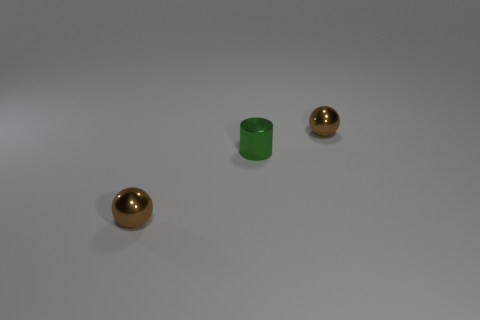Add 2 metallic things. How many objects exist? 5 Subtract 1 cylinders. How many cylinders are left? 0 Subtract all red cylinders. How many yellow spheres are left? 0 Subtract all green metallic objects. Subtract all large purple metallic blocks. How many objects are left? 2 Add 3 brown spheres. How many brown spheres are left? 5 Add 2 tiny green shiny cylinders. How many tiny green shiny cylinders exist? 3 Subtract 0 cyan blocks. How many objects are left? 3 Subtract all spheres. How many objects are left? 1 Subtract all yellow cylinders. Subtract all brown cubes. How many cylinders are left? 1 